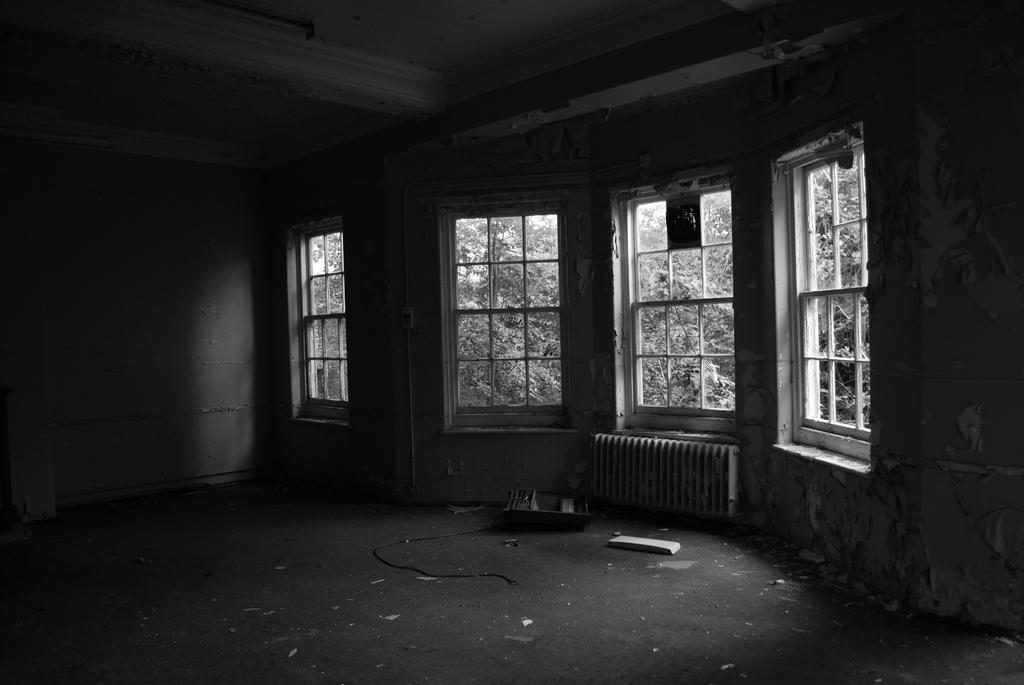What type of space is shown in the image? The image depicts a room. Can you describe a specific feature of the room? There are four windows in the center of the room. What can be seen through the windows? Trees are visible through the windows. What is present on the floor of the room? There are boxes and plastic objects on the floor. What time of day is it based on the image? The image does not provide any information about the time of day, so it cannot be determined. 